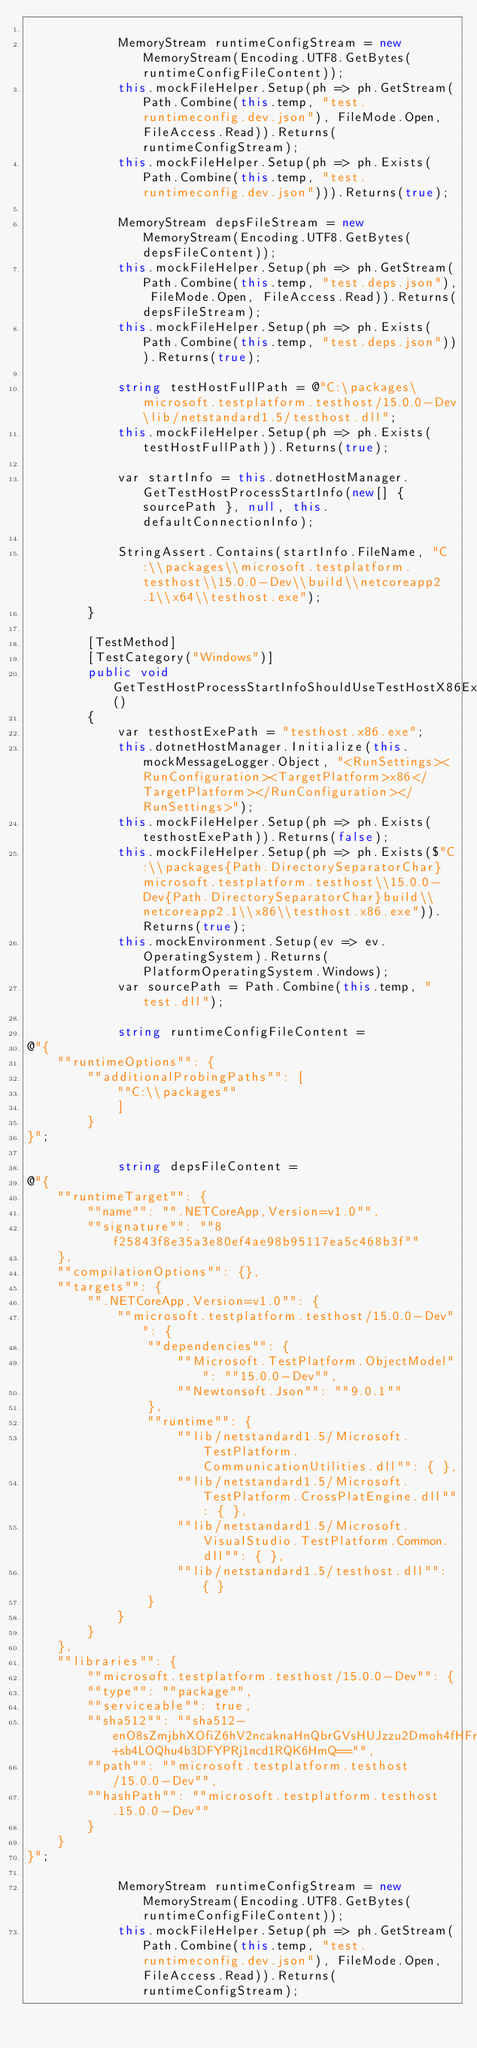Convert code to text. <code><loc_0><loc_0><loc_500><loc_500><_C#_>
            MemoryStream runtimeConfigStream = new MemoryStream(Encoding.UTF8.GetBytes(runtimeConfigFileContent));
            this.mockFileHelper.Setup(ph => ph.GetStream(Path.Combine(this.temp, "test.runtimeconfig.dev.json"), FileMode.Open, FileAccess.Read)).Returns(runtimeConfigStream);
            this.mockFileHelper.Setup(ph => ph.Exists(Path.Combine(this.temp, "test.runtimeconfig.dev.json"))).Returns(true);

            MemoryStream depsFileStream = new MemoryStream(Encoding.UTF8.GetBytes(depsFileContent));
            this.mockFileHelper.Setup(ph => ph.GetStream(Path.Combine(this.temp, "test.deps.json"), FileMode.Open, FileAccess.Read)).Returns(depsFileStream);
            this.mockFileHelper.Setup(ph => ph.Exists(Path.Combine(this.temp, "test.deps.json"))).Returns(true);

            string testHostFullPath = @"C:\packages\microsoft.testplatform.testhost/15.0.0-Dev\lib/netstandard1.5/testhost.dll";
            this.mockFileHelper.Setup(ph => ph.Exists(testHostFullPath)).Returns(true);

            var startInfo = this.dotnetHostManager.GetTestHostProcessStartInfo(new[] { sourcePath }, null, this.defaultConnectionInfo);

            StringAssert.Contains(startInfo.FileName, "C:\\packages\\microsoft.testplatform.testhost\\15.0.0-Dev\\build\\netcoreapp2.1\\x64\\testhost.exe");
        }

        [TestMethod]
        [TestCategory("Windows")]
        public void GetTestHostProcessStartInfoShouldUseTestHostX86ExeFromNugetIfNotFoundInSourceLocation()
        {
            var testhostExePath = "testhost.x86.exe";
            this.dotnetHostManager.Initialize(this.mockMessageLogger.Object, "<RunSettings><RunConfiguration><TargetPlatform>x86</TargetPlatform></RunConfiguration></RunSettings>");
            this.mockFileHelper.Setup(ph => ph.Exists(testhostExePath)).Returns(false);
            this.mockFileHelper.Setup(ph => ph.Exists($"C:\\packages{Path.DirectorySeparatorChar}microsoft.testplatform.testhost\\15.0.0-Dev{Path.DirectorySeparatorChar}build\\netcoreapp2.1\\x86\\testhost.x86.exe")).Returns(true);
            this.mockEnvironment.Setup(ev => ev.OperatingSystem).Returns(PlatformOperatingSystem.Windows);
            var sourcePath = Path.Combine(this.temp, "test.dll");

            string runtimeConfigFileContent =
@"{
    ""runtimeOptions"": {
        ""additionalProbingPaths"": [
            ""C:\\packages""
            ]
        }
}";

            string depsFileContent =
@"{
    ""runtimeTarget"": {
        ""name"": "".NETCoreApp,Version=v1.0"",
        ""signature"": ""8f25843f8e35a3e80ef4ae98b95117ea5c468b3f""
    },
    ""compilationOptions"": {},
    ""targets"": {
        "".NETCoreApp,Version=v1.0"": {
            ""microsoft.testplatform.testhost/15.0.0-Dev"": {
                ""dependencies"": {
                    ""Microsoft.TestPlatform.ObjectModel"": ""15.0.0-Dev"",
                    ""Newtonsoft.Json"": ""9.0.1""
                },
                ""runtime"": {
                    ""lib/netstandard1.5/Microsoft.TestPlatform.CommunicationUtilities.dll"": { },
                    ""lib/netstandard1.5/Microsoft.TestPlatform.CrossPlatEngine.dll"": { },
                    ""lib/netstandard1.5/Microsoft.VisualStudio.TestPlatform.Common.dll"": { },
                    ""lib/netstandard1.5/testhost.dll"": { }
                }
            }
        }
    },
    ""libraries"": {
        ""microsoft.testplatform.testhost/15.0.0-Dev"": {
        ""type"": ""package"",
        ""serviceable"": true,
        ""sha512"": ""sha512-enO8sZmjbhXOfiZ6hV2ncaknaHnQbrGVsHUJzzu2Dmoh4fHFro4BF1Y4+sb4LOQhu4b3DFYPRj1ncd1RQK6HmQ=="",
        ""path"": ""microsoft.testplatform.testhost/15.0.0-Dev"",
        ""hashPath"": ""microsoft.testplatform.testhost.15.0.0-Dev""
        }
    }
}";

            MemoryStream runtimeConfigStream = new MemoryStream(Encoding.UTF8.GetBytes(runtimeConfigFileContent));
            this.mockFileHelper.Setup(ph => ph.GetStream(Path.Combine(this.temp, "test.runtimeconfig.dev.json"), FileMode.Open, FileAccess.Read)).Returns(runtimeConfigStream);</code> 